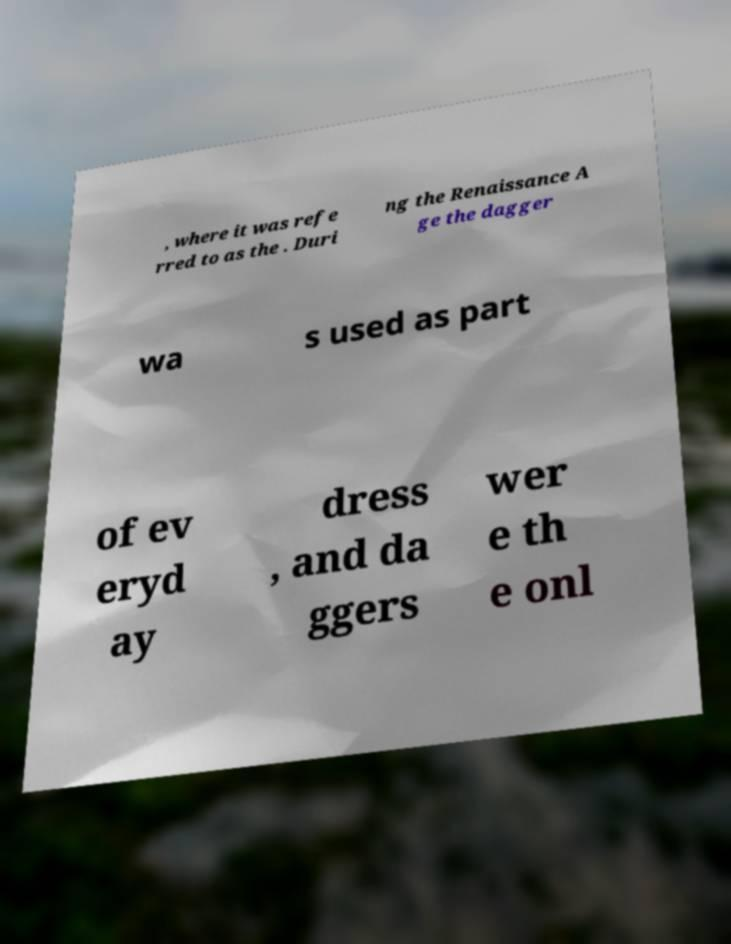For documentation purposes, I need the text within this image transcribed. Could you provide that? , where it was refe rred to as the . Duri ng the Renaissance A ge the dagger wa s used as part of ev eryd ay dress , and da ggers wer e th e onl 